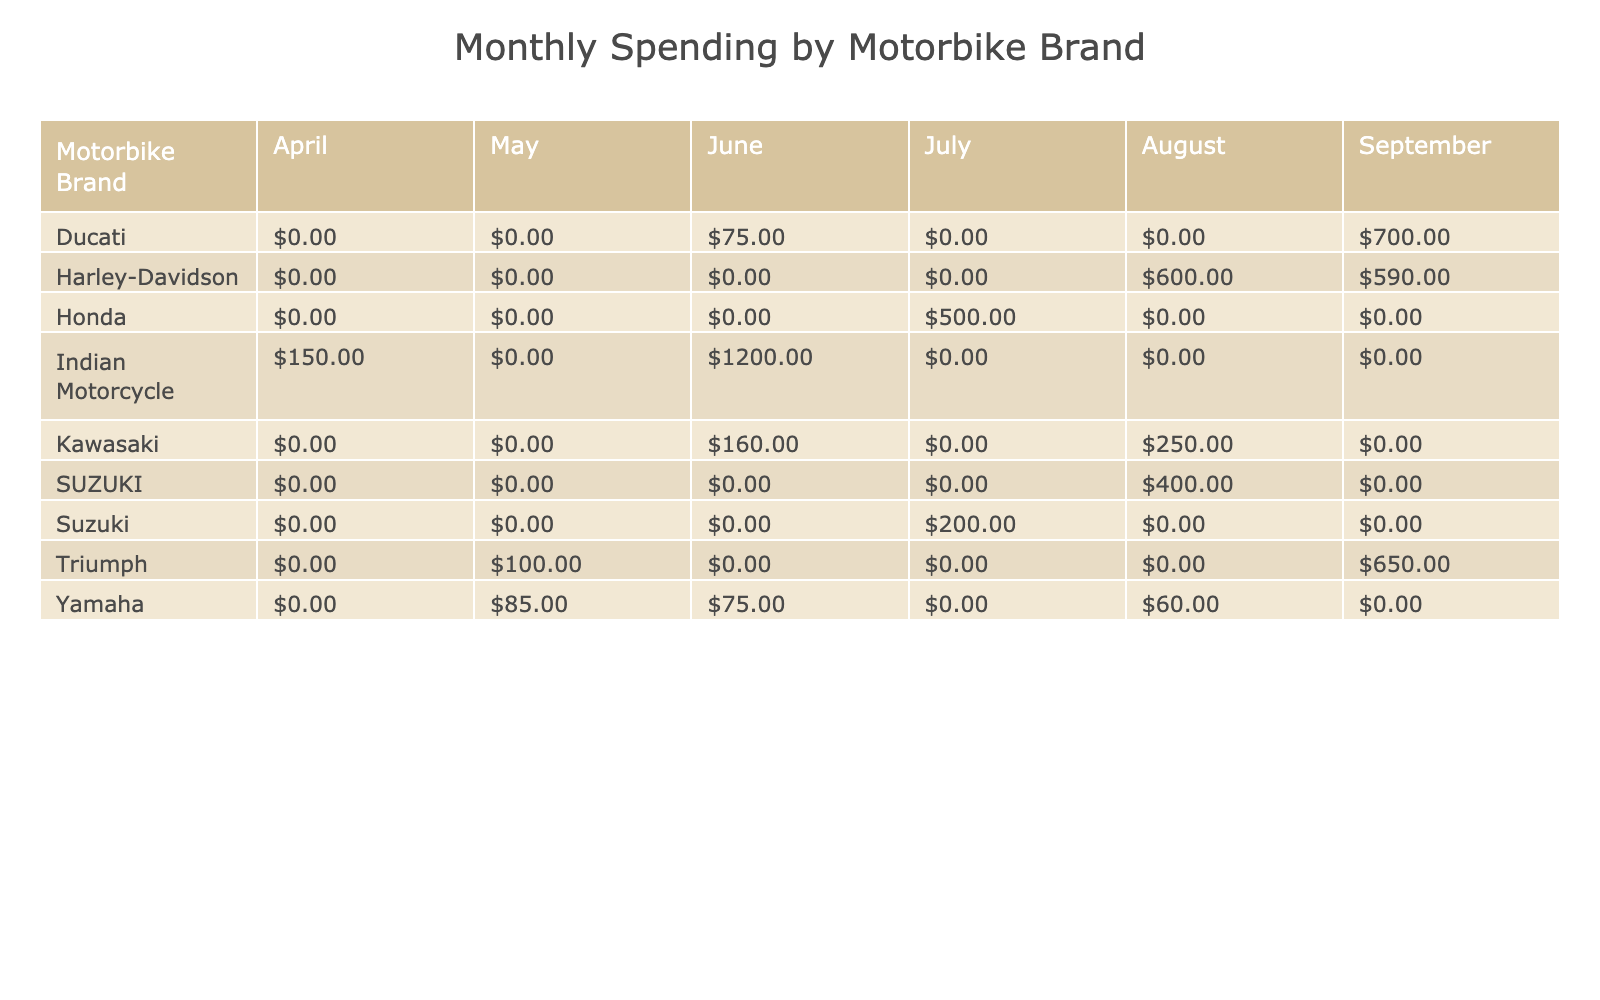What is the total spending on Yamaha motorbikes in April? In the table, look at the row for Yamaha under the April column. The value for Yamaha in April is 0, indicating no spending in that month.
Answer: 0 Which month had the highest total spending for Honda? Check the Honda row in the table for each month's spending values: April (0), May (0), June (80), July (120), August (300), September (0). The highest value is in August at 300.
Answer: 300 What type of service was the most costly for Kawasaki? In the Kawasaki row, identify the spending for each service type from different months and find the maximum value which is 250 for Engine Tune-up in August.
Answer: Engine Tune-up Which motorbike brand had the least spending overall? Sum the spending across all months for each brand: Yamaha (75), Honda (400), Kawasaki (660), Harley-Davidson (690), Suzuki (200), Ducati (775), Triumph (730), Indian Motorcycle (1800). The least is Yamaha at 75.
Answer: Yamaha Did Female customers spend more on average than Male customers? Calculate the average spending for male customers by adding their total spending (75 + 120 + 250 + 90 + 200 + 100 + 150 + 500 + 300 + 110 + 400 + 700 + 1200 + 600 + 650 = 4650) and dividing by the number of male customers (10), which is 465. For female customers, total is 75 + 120 + 90 + 200 + 400 + 50 + 650 = 1585, divide by 10 (8 female customers), giving an average of 198.75. Comparatively, males spend more on average.
Answer: Yes What was the overall spending in September for all motorbike brands combined? Check the September column to get the values: Yamaha (0), Honda (0), Kawasaki (0), Harley-Davidson (0), Suzuki (0), Ducati (0), Triumph (650), Indian Motorcycle (0). The total spending is 650.
Answer: 650 Which brand had the second-highest spending in July? For July, the spending values are: Yamaha (80), Honda (120), Kawasaki (0), Harley-Davidson (0), Suzuki (200), Ducati (0), Triumph (100), Indian Motorcycle (0). The highest is Suzuki at 200, and the second-highest is Honda at 120.
Answer: Honda What is the total spending for Indian Motorcycle services? Look at the Indian Motorcycle row and sum its service spending across the months: 150 (April) + 0 (May) + 0 (June) + 0 (July) + 600 (August) + 1200 (September) = 1800.
Answer: 1800 Which service type was performed in August that cost more than $500? Review the August spending for all service types: Yamaha (0), Honda (0), Kawasaki (0), Harley-Davidson (600 for Exhaust System Upgrade), Suzuki (0), Ducati (0), Triumph (0), Indian Motorcycle (600). The only service over $500 is Harley-Davidson's Exhaust System Upgrade at 600.
Answer: Exhaust System Upgrade What was the total spending for female customers in June? For June, female spending includes: Yamaha (75), Honda (0), Kawasaki (0), Harley-Davidson (0), Suzuki (0), Ducati (0), Triumph (0), and the total is 75.
Answer: 75 How many different Motorbike Brands had a service in May? Check the May values: Yamaha (0), Honda (0), Kawasaki (0), Harley-Davidson (0), Suzuki (0), Ducati (0), Triumph (100), Indian Motorcycle (0). Only Triumph had a service in May, thus only one brand.
Answer: 1 